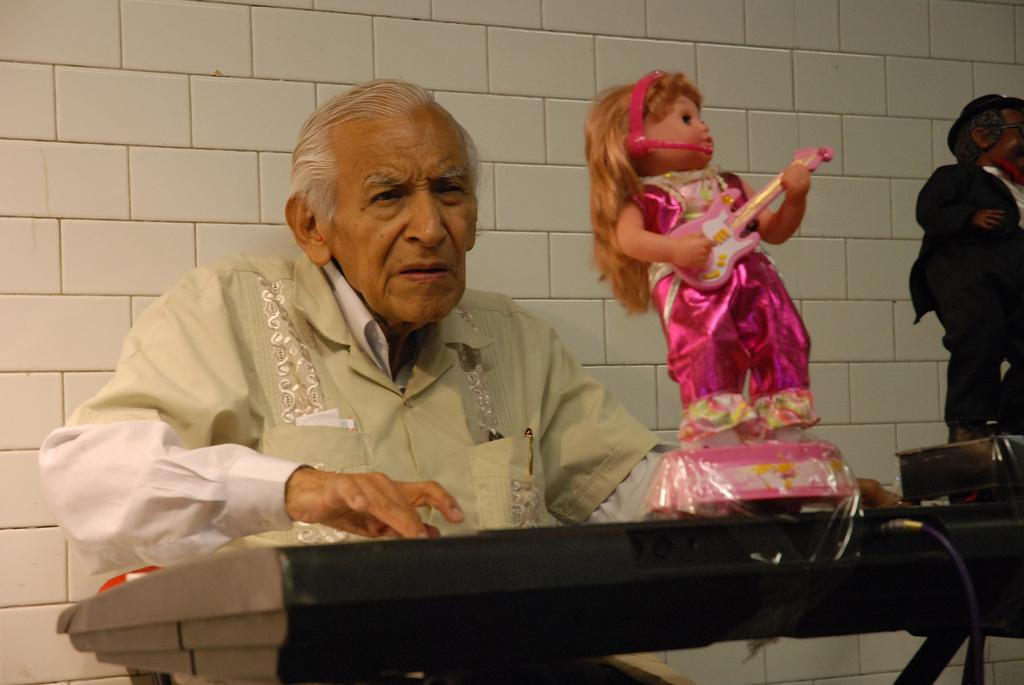What is the man in the image doing? The man is playing a musical instrument. Are there any objects on the musical instrument? Yes, there are two toys on the musical instrument. What can be seen in the background of the image? There is a wall in the background of the image. What is the man's daughter doing during the summer in the image? There is no mention of a daughter or summer in the image, so we cannot answer that question. 